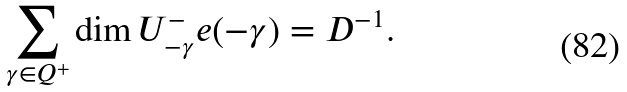<formula> <loc_0><loc_0><loc_500><loc_500>\sum _ { \gamma \in Q ^ { + } } \dim U ^ { - } _ { - \gamma } e ( - \gamma ) = D ^ { - 1 } .</formula> 